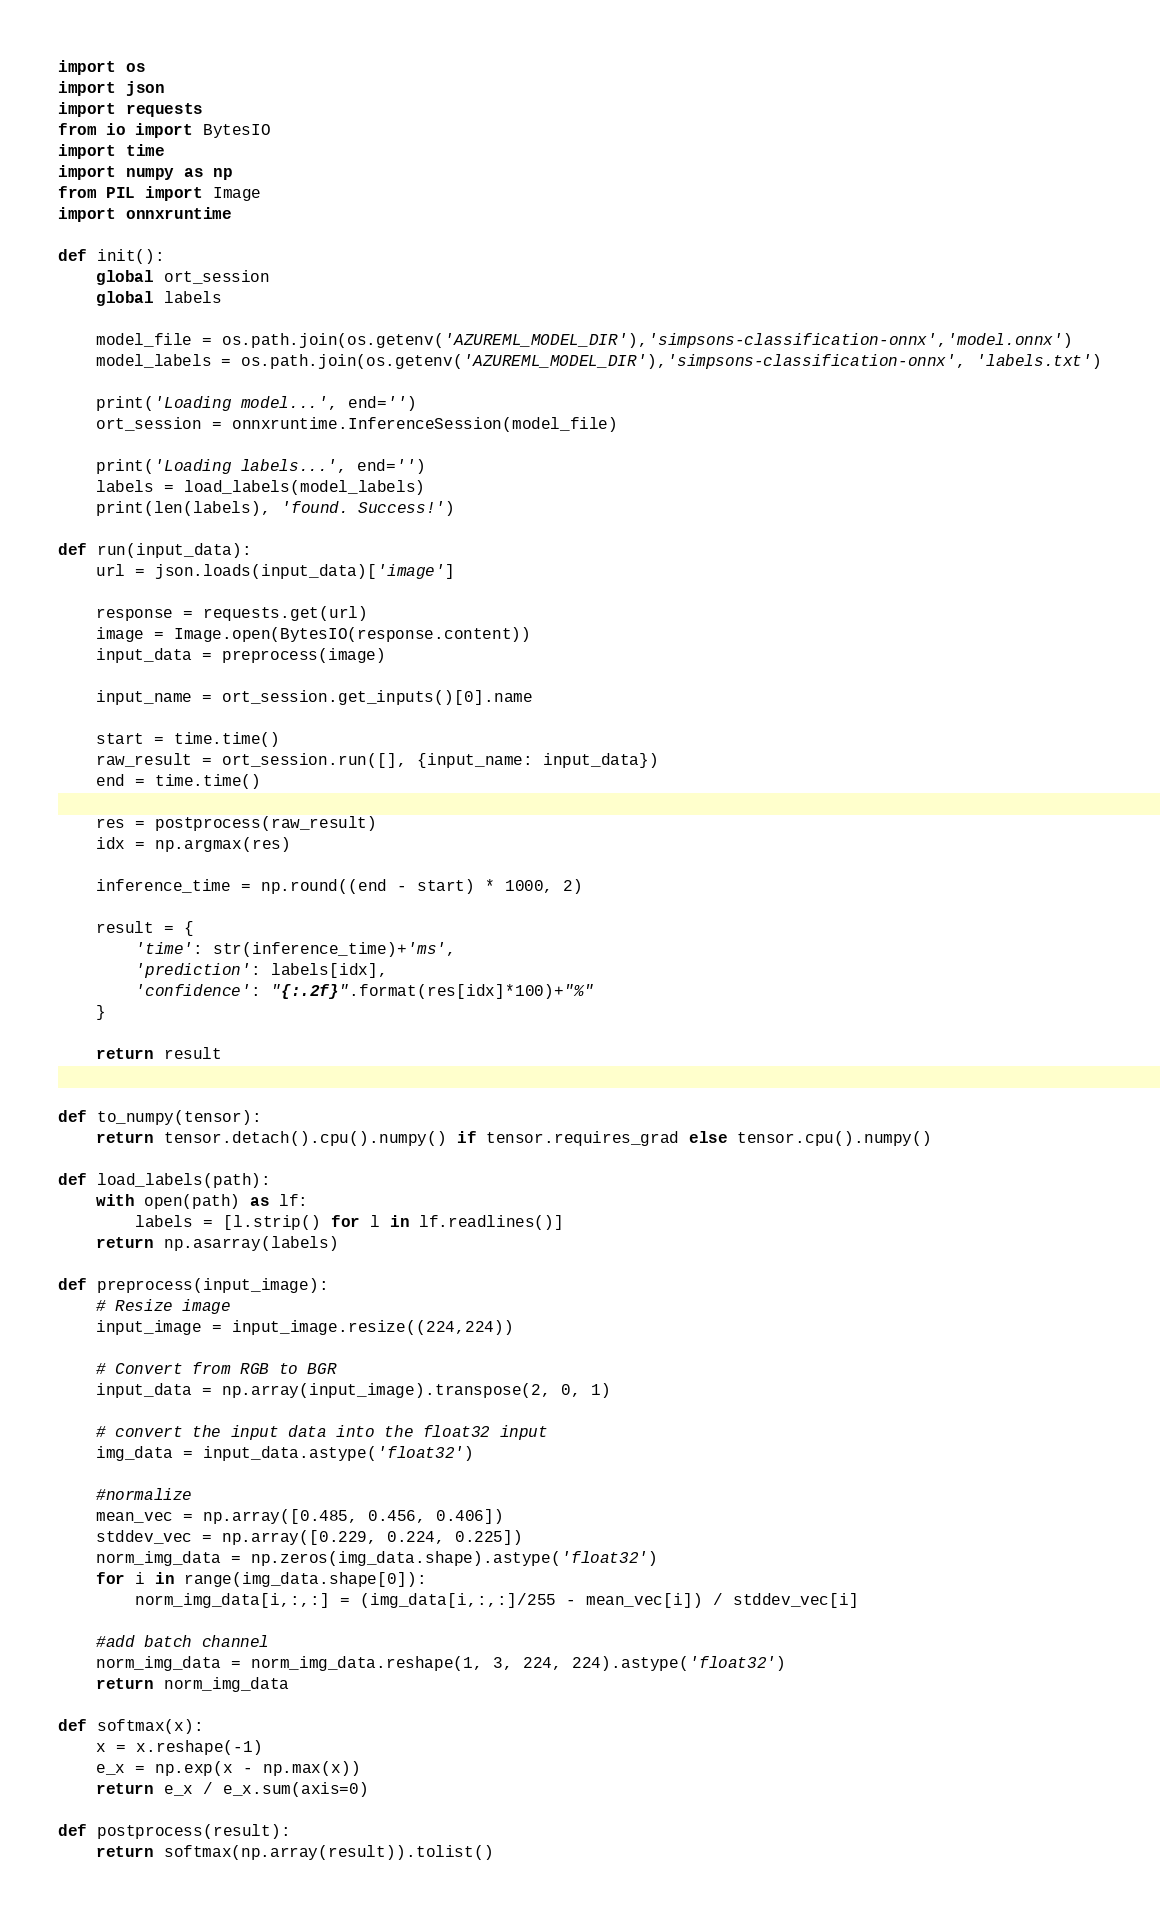<code> <loc_0><loc_0><loc_500><loc_500><_Python_>import os
import json
import requests
from io import BytesIO
import time
import numpy as np
from PIL import Image
import onnxruntime

def init():
    global ort_session
    global labels

    model_file = os.path.join(os.getenv('AZUREML_MODEL_DIR'),'simpsons-classification-onnx','model.onnx')
    model_labels = os.path.join(os.getenv('AZUREML_MODEL_DIR'),'simpsons-classification-onnx', 'labels.txt')
    
    print('Loading model...', end='')
    ort_session = onnxruntime.InferenceSession(model_file)

    print('Loading labels...', end='')
    labels = load_labels(model_labels)
    print(len(labels), 'found. Success!')

def run(input_data):
    url = json.loads(input_data)['image']

    response = requests.get(url)
    image = Image.open(BytesIO(response.content))
    input_data = preprocess(image)

    input_name = ort_session.get_inputs()[0].name  
   
    start = time.time()
    raw_result = ort_session.run([], {input_name: input_data})
    end = time.time()

    res = postprocess(raw_result)
    idx = np.argmax(res)

    inference_time = np.round((end - start) * 1000, 2)

    result = {
        'time': str(inference_time)+'ms',
        'prediction': labels[idx],
        'confidence': "{:.2f}".format(res[idx]*100)+"%"
    }

    return result


def to_numpy(tensor):
    return tensor.detach().cpu().numpy() if tensor.requires_grad else tensor.cpu().numpy()

def load_labels(path):
    with open(path) as lf:
        labels = [l.strip() for l in lf.readlines()]
    return np.asarray(labels)

def preprocess(input_image):
    # Resize image
    input_image = input_image.resize((224,224)) 

    # Convert from RGB to BGR
    input_data = np.array(input_image).transpose(2, 0, 1)

    # convert the input data into the float32 input
    img_data = input_data.astype('float32')

    #normalize
    mean_vec = np.array([0.485, 0.456, 0.406])
    stddev_vec = np.array([0.229, 0.224, 0.225])
    norm_img_data = np.zeros(img_data.shape).astype('float32')
    for i in range(img_data.shape[0]):
        norm_img_data[i,:,:] = (img_data[i,:,:]/255 - mean_vec[i]) / stddev_vec[i]
  
    #add batch channel
    norm_img_data = norm_img_data.reshape(1, 3, 224, 224).astype('float32')
    return norm_img_data

def softmax(x):
    x = x.reshape(-1)
    e_x = np.exp(x - np.max(x))
    return e_x / e_x.sum(axis=0)

def postprocess(result):
    return softmax(np.array(result)).tolist()</code> 